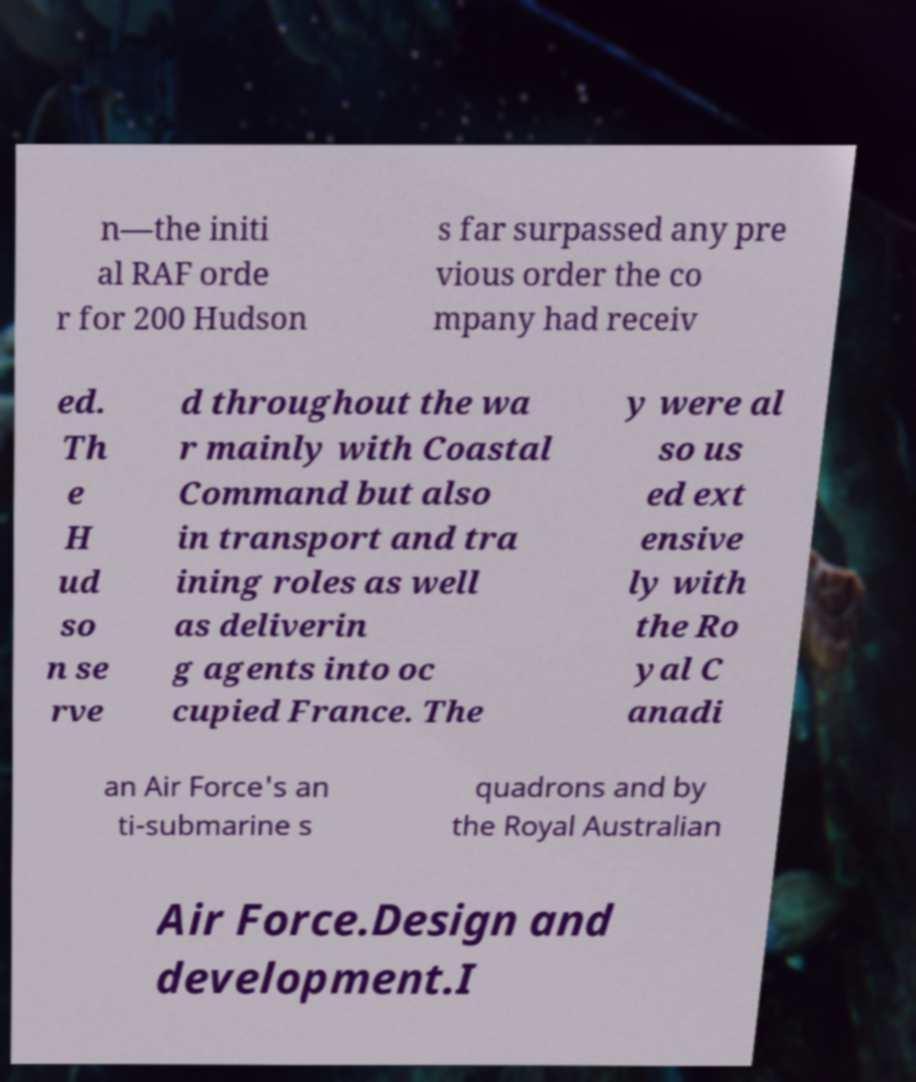I need the written content from this picture converted into text. Can you do that? n—the initi al RAF orde r for 200 Hudson s far surpassed any pre vious order the co mpany had receiv ed. Th e H ud so n se rve d throughout the wa r mainly with Coastal Command but also in transport and tra ining roles as well as deliverin g agents into oc cupied France. The y were al so us ed ext ensive ly with the Ro yal C anadi an Air Force's an ti-submarine s quadrons and by the Royal Australian Air Force.Design and development.I 